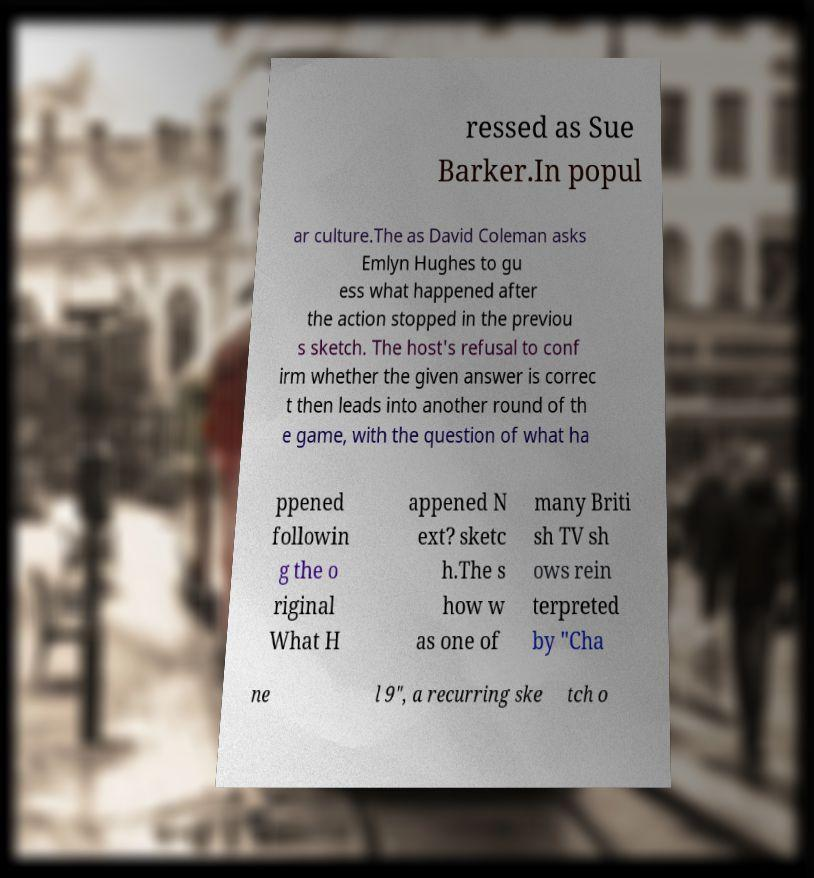Could you extract and type out the text from this image? ressed as Sue Barker.In popul ar culture.The as David Coleman asks Emlyn Hughes to gu ess what happened after the action stopped in the previou s sketch. The host's refusal to conf irm whether the given answer is correc t then leads into another round of th e game, with the question of what ha ppened followin g the o riginal What H appened N ext? sketc h.The s how w as one of many Briti sh TV sh ows rein terpreted by "Cha ne l 9", a recurring ske tch o 